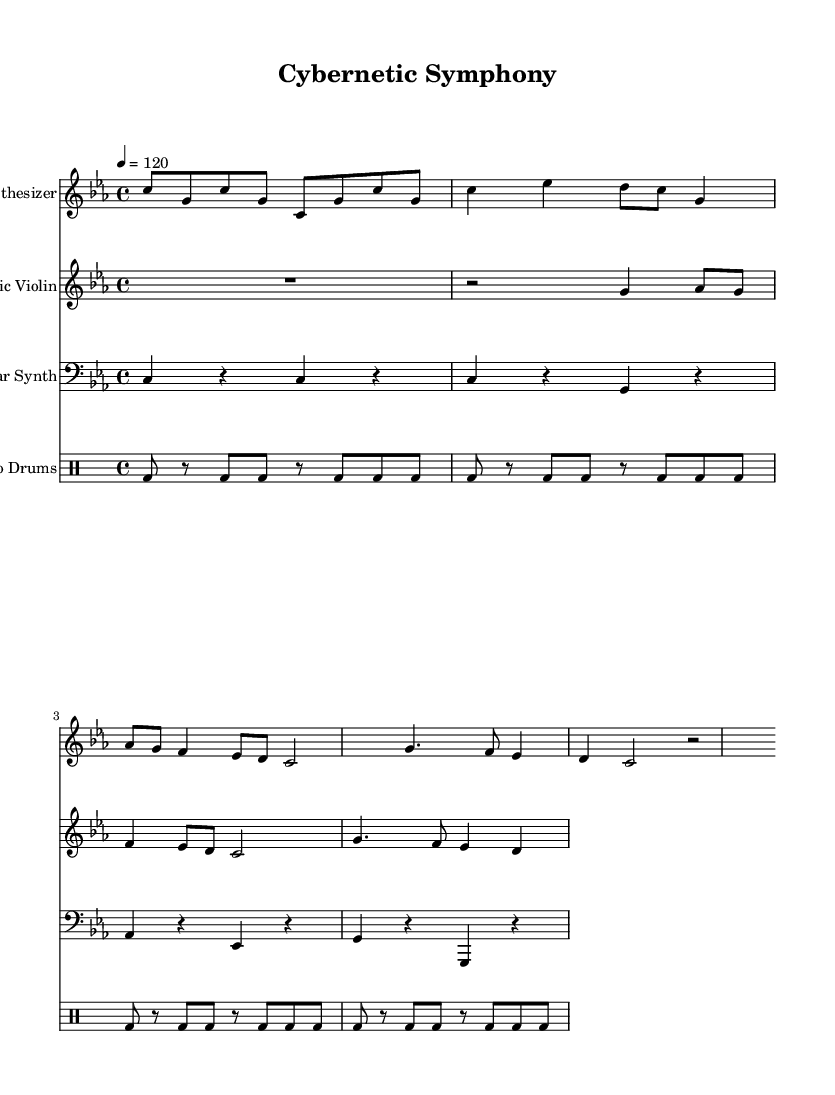What is the key signature of this music? The key signature is C minor, which has three flats: B flat, E flat, and A flat. This is identified from the key signature marking at the beginning of the staff, which indicates the music is in C minor.
Answer: C minor What is the time signature? The time signature is 4/4, which means there are four beats in each measure and the quarter note gets one beat. This can be seen at the start of the piece, shown as two numbers stacked, with the upper number indicating the beats per measure.
Answer: 4/4 What is the tempo marking? The tempo marking is 120 beats per minute, indicated in the score by the term "4 = 120". This indicates the speed of the music and how fast the quarter notes should be played.
Answer: 120 How many measures are in the piece for the synthesizer? The synthesizer part contains eight measures, counted by tallying each measure from the beginning of the part to the end. Each measure is separated by vertical lines.
Answer: 8 What type of drum pattern is used in the taiko drums? The taiko drums use a repetitive bass drum pattern characterized by consistent eighth-note beats. By analyzing the drummode notation, we can see a cycle of bass drum hits occurring regularly, confirming it is a specific rhythmic structure typical in taiko music.
Answer: Repetitive How does the electric violin contribute to the overall texture? The electric violin adds melodic phrasing with syncopated rhythms, complementing the synthesizer's harmony and providing a contrasting timbre. This is analyzed through its unique note patterns and rests, which infuse liveliness and variation into the music.
Answer: Melodic phrasing What instruments are involved in this composition? The composition includes a synthesizer, electric violin, modular synth, and taiko drums. Each instrument is clearly labeled in the score and provides a distinctive role, showcasing the blend of technological and traditional elements.
Answer: Synthesizer, electric violin, modular synth, taiko drums 